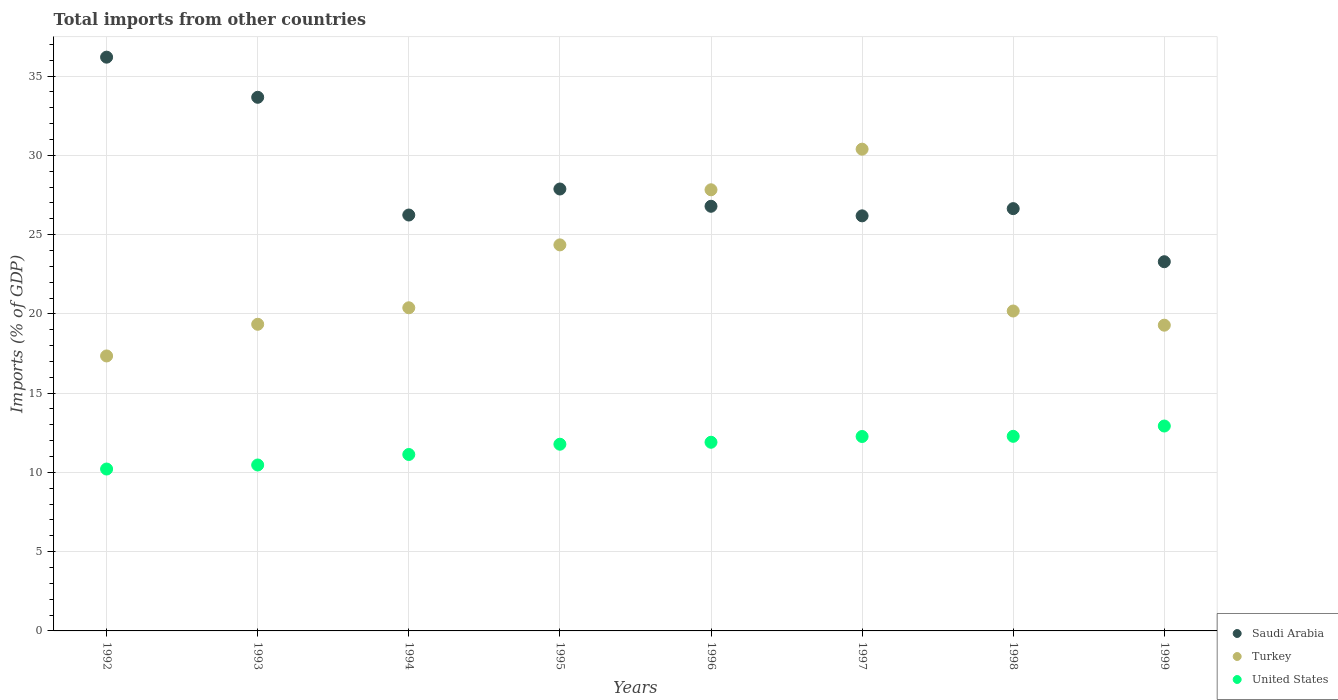How many different coloured dotlines are there?
Provide a short and direct response. 3. Is the number of dotlines equal to the number of legend labels?
Your answer should be compact. Yes. What is the total imports in Saudi Arabia in 1993?
Ensure brevity in your answer.  33.66. Across all years, what is the maximum total imports in United States?
Offer a terse response. 12.92. Across all years, what is the minimum total imports in Turkey?
Your answer should be very brief. 17.35. In which year was the total imports in Turkey maximum?
Your response must be concise. 1997. What is the total total imports in United States in the graph?
Your answer should be compact. 92.95. What is the difference between the total imports in Turkey in 1992 and that in 1996?
Your answer should be very brief. -10.48. What is the difference between the total imports in United States in 1994 and the total imports in Turkey in 1996?
Offer a very short reply. -16.7. What is the average total imports in Saudi Arabia per year?
Your response must be concise. 28.36. In the year 1996, what is the difference between the total imports in United States and total imports in Saudi Arabia?
Keep it short and to the point. -14.89. What is the ratio of the total imports in Turkey in 1994 to that in 1995?
Your answer should be very brief. 0.84. What is the difference between the highest and the second highest total imports in Saudi Arabia?
Ensure brevity in your answer.  2.53. What is the difference between the highest and the lowest total imports in Saudi Arabia?
Offer a terse response. 12.9. Is the total imports in United States strictly greater than the total imports in Turkey over the years?
Provide a succinct answer. No. Is the total imports in Saudi Arabia strictly less than the total imports in United States over the years?
Your response must be concise. No. How many dotlines are there?
Keep it short and to the point. 3. How many years are there in the graph?
Provide a succinct answer. 8. Are the values on the major ticks of Y-axis written in scientific E-notation?
Offer a terse response. No. Does the graph contain any zero values?
Provide a succinct answer. No. Does the graph contain grids?
Your answer should be very brief. Yes. Where does the legend appear in the graph?
Offer a very short reply. Bottom right. How many legend labels are there?
Your answer should be compact. 3. How are the legend labels stacked?
Your answer should be very brief. Vertical. What is the title of the graph?
Your response must be concise. Total imports from other countries. What is the label or title of the X-axis?
Provide a succinct answer. Years. What is the label or title of the Y-axis?
Your answer should be compact. Imports (% of GDP). What is the Imports (% of GDP) in Saudi Arabia in 1992?
Provide a short and direct response. 36.19. What is the Imports (% of GDP) of Turkey in 1992?
Offer a very short reply. 17.35. What is the Imports (% of GDP) of United States in 1992?
Your response must be concise. 10.21. What is the Imports (% of GDP) of Saudi Arabia in 1993?
Offer a terse response. 33.66. What is the Imports (% of GDP) in Turkey in 1993?
Your answer should be very brief. 19.34. What is the Imports (% of GDP) of United States in 1993?
Offer a very short reply. 10.47. What is the Imports (% of GDP) in Saudi Arabia in 1994?
Your answer should be compact. 26.23. What is the Imports (% of GDP) in Turkey in 1994?
Your answer should be compact. 20.38. What is the Imports (% of GDP) in United States in 1994?
Keep it short and to the point. 11.13. What is the Imports (% of GDP) of Saudi Arabia in 1995?
Ensure brevity in your answer.  27.88. What is the Imports (% of GDP) in Turkey in 1995?
Give a very brief answer. 24.35. What is the Imports (% of GDP) in United States in 1995?
Offer a terse response. 11.78. What is the Imports (% of GDP) of Saudi Arabia in 1996?
Your answer should be very brief. 26.79. What is the Imports (% of GDP) of Turkey in 1996?
Your answer should be compact. 27.83. What is the Imports (% of GDP) of United States in 1996?
Give a very brief answer. 11.9. What is the Imports (% of GDP) of Saudi Arabia in 1997?
Offer a very short reply. 26.18. What is the Imports (% of GDP) in Turkey in 1997?
Your response must be concise. 30.39. What is the Imports (% of GDP) in United States in 1997?
Your answer should be very brief. 12.26. What is the Imports (% of GDP) in Saudi Arabia in 1998?
Offer a very short reply. 26.64. What is the Imports (% of GDP) of Turkey in 1998?
Offer a very short reply. 20.18. What is the Imports (% of GDP) in United States in 1998?
Your response must be concise. 12.27. What is the Imports (% of GDP) in Saudi Arabia in 1999?
Your answer should be compact. 23.29. What is the Imports (% of GDP) in Turkey in 1999?
Make the answer very short. 19.29. What is the Imports (% of GDP) of United States in 1999?
Your response must be concise. 12.92. Across all years, what is the maximum Imports (% of GDP) of Saudi Arabia?
Ensure brevity in your answer.  36.19. Across all years, what is the maximum Imports (% of GDP) in Turkey?
Your answer should be very brief. 30.39. Across all years, what is the maximum Imports (% of GDP) of United States?
Provide a short and direct response. 12.92. Across all years, what is the minimum Imports (% of GDP) of Saudi Arabia?
Offer a very short reply. 23.29. Across all years, what is the minimum Imports (% of GDP) of Turkey?
Provide a short and direct response. 17.35. Across all years, what is the minimum Imports (% of GDP) in United States?
Offer a very short reply. 10.21. What is the total Imports (% of GDP) of Saudi Arabia in the graph?
Ensure brevity in your answer.  226.86. What is the total Imports (% of GDP) in Turkey in the graph?
Your response must be concise. 179.1. What is the total Imports (% of GDP) in United States in the graph?
Offer a terse response. 92.95. What is the difference between the Imports (% of GDP) of Saudi Arabia in 1992 and that in 1993?
Provide a short and direct response. 2.53. What is the difference between the Imports (% of GDP) of Turkey in 1992 and that in 1993?
Provide a short and direct response. -2. What is the difference between the Imports (% of GDP) in United States in 1992 and that in 1993?
Offer a terse response. -0.25. What is the difference between the Imports (% of GDP) in Saudi Arabia in 1992 and that in 1994?
Provide a succinct answer. 9.96. What is the difference between the Imports (% of GDP) of Turkey in 1992 and that in 1994?
Ensure brevity in your answer.  -3.04. What is the difference between the Imports (% of GDP) in United States in 1992 and that in 1994?
Ensure brevity in your answer.  -0.92. What is the difference between the Imports (% of GDP) of Saudi Arabia in 1992 and that in 1995?
Offer a terse response. 8.32. What is the difference between the Imports (% of GDP) in Turkey in 1992 and that in 1995?
Provide a short and direct response. -7.01. What is the difference between the Imports (% of GDP) of United States in 1992 and that in 1995?
Provide a short and direct response. -1.56. What is the difference between the Imports (% of GDP) in Saudi Arabia in 1992 and that in 1996?
Offer a very short reply. 9.41. What is the difference between the Imports (% of GDP) of Turkey in 1992 and that in 1996?
Offer a very short reply. -10.48. What is the difference between the Imports (% of GDP) of United States in 1992 and that in 1996?
Offer a very short reply. -1.69. What is the difference between the Imports (% of GDP) in Saudi Arabia in 1992 and that in 1997?
Offer a very short reply. 10.01. What is the difference between the Imports (% of GDP) of Turkey in 1992 and that in 1997?
Provide a short and direct response. -13.04. What is the difference between the Imports (% of GDP) in United States in 1992 and that in 1997?
Your answer should be compact. -2.05. What is the difference between the Imports (% of GDP) of Saudi Arabia in 1992 and that in 1998?
Make the answer very short. 9.55. What is the difference between the Imports (% of GDP) of Turkey in 1992 and that in 1998?
Provide a succinct answer. -2.84. What is the difference between the Imports (% of GDP) in United States in 1992 and that in 1998?
Provide a short and direct response. -2.06. What is the difference between the Imports (% of GDP) of Saudi Arabia in 1992 and that in 1999?
Ensure brevity in your answer.  12.9. What is the difference between the Imports (% of GDP) in Turkey in 1992 and that in 1999?
Ensure brevity in your answer.  -1.94. What is the difference between the Imports (% of GDP) in United States in 1992 and that in 1999?
Ensure brevity in your answer.  -2.71. What is the difference between the Imports (% of GDP) in Saudi Arabia in 1993 and that in 1994?
Ensure brevity in your answer.  7.43. What is the difference between the Imports (% of GDP) of Turkey in 1993 and that in 1994?
Provide a short and direct response. -1.04. What is the difference between the Imports (% of GDP) of United States in 1993 and that in 1994?
Make the answer very short. -0.66. What is the difference between the Imports (% of GDP) in Saudi Arabia in 1993 and that in 1995?
Offer a terse response. 5.78. What is the difference between the Imports (% of GDP) in Turkey in 1993 and that in 1995?
Your answer should be compact. -5.01. What is the difference between the Imports (% of GDP) of United States in 1993 and that in 1995?
Ensure brevity in your answer.  -1.31. What is the difference between the Imports (% of GDP) in Saudi Arabia in 1993 and that in 1996?
Keep it short and to the point. 6.87. What is the difference between the Imports (% of GDP) of Turkey in 1993 and that in 1996?
Ensure brevity in your answer.  -8.48. What is the difference between the Imports (% of GDP) of United States in 1993 and that in 1996?
Your answer should be compact. -1.43. What is the difference between the Imports (% of GDP) in Saudi Arabia in 1993 and that in 1997?
Give a very brief answer. 7.48. What is the difference between the Imports (% of GDP) in Turkey in 1993 and that in 1997?
Your answer should be compact. -11.05. What is the difference between the Imports (% of GDP) of United States in 1993 and that in 1997?
Ensure brevity in your answer.  -1.8. What is the difference between the Imports (% of GDP) of Saudi Arabia in 1993 and that in 1998?
Make the answer very short. 7.02. What is the difference between the Imports (% of GDP) of Turkey in 1993 and that in 1998?
Ensure brevity in your answer.  -0.84. What is the difference between the Imports (% of GDP) in United States in 1993 and that in 1998?
Give a very brief answer. -1.81. What is the difference between the Imports (% of GDP) of Saudi Arabia in 1993 and that in 1999?
Provide a short and direct response. 10.37. What is the difference between the Imports (% of GDP) of Turkey in 1993 and that in 1999?
Give a very brief answer. 0.06. What is the difference between the Imports (% of GDP) of United States in 1993 and that in 1999?
Your answer should be compact. -2.46. What is the difference between the Imports (% of GDP) in Saudi Arabia in 1994 and that in 1995?
Your answer should be compact. -1.64. What is the difference between the Imports (% of GDP) of Turkey in 1994 and that in 1995?
Your answer should be very brief. -3.97. What is the difference between the Imports (% of GDP) of United States in 1994 and that in 1995?
Offer a terse response. -0.65. What is the difference between the Imports (% of GDP) of Saudi Arabia in 1994 and that in 1996?
Offer a terse response. -0.55. What is the difference between the Imports (% of GDP) of Turkey in 1994 and that in 1996?
Your answer should be very brief. -7.44. What is the difference between the Imports (% of GDP) in United States in 1994 and that in 1996?
Keep it short and to the point. -0.77. What is the difference between the Imports (% of GDP) in Saudi Arabia in 1994 and that in 1997?
Keep it short and to the point. 0.05. What is the difference between the Imports (% of GDP) in Turkey in 1994 and that in 1997?
Your response must be concise. -10. What is the difference between the Imports (% of GDP) of United States in 1994 and that in 1997?
Your response must be concise. -1.13. What is the difference between the Imports (% of GDP) of Saudi Arabia in 1994 and that in 1998?
Ensure brevity in your answer.  -0.4. What is the difference between the Imports (% of GDP) in Turkey in 1994 and that in 1998?
Give a very brief answer. 0.2. What is the difference between the Imports (% of GDP) in United States in 1994 and that in 1998?
Your answer should be very brief. -1.15. What is the difference between the Imports (% of GDP) of Saudi Arabia in 1994 and that in 1999?
Make the answer very short. 2.95. What is the difference between the Imports (% of GDP) in Turkey in 1994 and that in 1999?
Your answer should be very brief. 1.1. What is the difference between the Imports (% of GDP) in United States in 1994 and that in 1999?
Make the answer very short. -1.8. What is the difference between the Imports (% of GDP) of Saudi Arabia in 1995 and that in 1996?
Offer a terse response. 1.09. What is the difference between the Imports (% of GDP) in Turkey in 1995 and that in 1996?
Your answer should be very brief. -3.48. What is the difference between the Imports (% of GDP) of United States in 1995 and that in 1996?
Provide a succinct answer. -0.12. What is the difference between the Imports (% of GDP) of Saudi Arabia in 1995 and that in 1997?
Give a very brief answer. 1.69. What is the difference between the Imports (% of GDP) in Turkey in 1995 and that in 1997?
Ensure brevity in your answer.  -6.04. What is the difference between the Imports (% of GDP) of United States in 1995 and that in 1997?
Provide a short and direct response. -0.49. What is the difference between the Imports (% of GDP) in Saudi Arabia in 1995 and that in 1998?
Make the answer very short. 1.24. What is the difference between the Imports (% of GDP) in Turkey in 1995 and that in 1998?
Keep it short and to the point. 4.17. What is the difference between the Imports (% of GDP) in United States in 1995 and that in 1998?
Give a very brief answer. -0.5. What is the difference between the Imports (% of GDP) of Saudi Arabia in 1995 and that in 1999?
Your response must be concise. 4.59. What is the difference between the Imports (% of GDP) of Turkey in 1995 and that in 1999?
Give a very brief answer. 5.07. What is the difference between the Imports (% of GDP) of United States in 1995 and that in 1999?
Keep it short and to the point. -1.15. What is the difference between the Imports (% of GDP) in Saudi Arabia in 1996 and that in 1997?
Make the answer very short. 0.6. What is the difference between the Imports (% of GDP) in Turkey in 1996 and that in 1997?
Provide a short and direct response. -2.56. What is the difference between the Imports (% of GDP) in United States in 1996 and that in 1997?
Provide a short and direct response. -0.36. What is the difference between the Imports (% of GDP) of Saudi Arabia in 1996 and that in 1998?
Provide a short and direct response. 0.15. What is the difference between the Imports (% of GDP) of Turkey in 1996 and that in 1998?
Your answer should be compact. 7.65. What is the difference between the Imports (% of GDP) of United States in 1996 and that in 1998?
Your response must be concise. -0.37. What is the difference between the Imports (% of GDP) of Saudi Arabia in 1996 and that in 1999?
Offer a terse response. 3.5. What is the difference between the Imports (% of GDP) in Turkey in 1996 and that in 1999?
Provide a succinct answer. 8.54. What is the difference between the Imports (% of GDP) in United States in 1996 and that in 1999?
Give a very brief answer. -1.02. What is the difference between the Imports (% of GDP) in Saudi Arabia in 1997 and that in 1998?
Offer a very short reply. -0.46. What is the difference between the Imports (% of GDP) of Turkey in 1997 and that in 1998?
Your answer should be very brief. 10.21. What is the difference between the Imports (% of GDP) in United States in 1997 and that in 1998?
Offer a terse response. -0.01. What is the difference between the Imports (% of GDP) in Saudi Arabia in 1997 and that in 1999?
Provide a short and direct response. 2.89. What is the difference between the Imports (% of GDP) of Turkey in 1997 and that in 1999?
Ensure brevity in your answer.  11.1. What is the difference between the Imports (% of GDP) in United States in 1997 and that in 1999?
Keep it short and to the point. -0.66. What is the difference between the Imports (% of GDP) in Saudi Arabia in 1998 and that in 1999?
Your answer should be compact. 3.35. What is the difference between the Imports (% of GDP) of Turkey in 1998 and that in 1999?
Provide a short and direct response. 0.89. What is the difference between the Imports (% of GDP) in United States in 1998 and that in 1999?
Give a very brief answer. -0.65. What is the difference between the Imports (% of GDP) of Saudi Arabia in 1992 and the Imports (% of GDP) of Turkey in 1993?
Make the answer very short. 16.85. What is the difference between the Imports (% of GDP) in Saudi Arabia in 1992 and the Imports (% of GDP) in United States in 1993?
Offer a terse response. 25.73. What is the difference between the Imports (% of GDP) in Turkey in 1992 and the Imports (% of GDP) in United States in 1993?
Your response must be concise. 6.88. What is the difference between the Imports (% of GDP) in Saudi Arabia in 1992 and the Imports (% of GDP) in Turkey in 1994?
Your answer should be compact. 15.81. What is the difference between the Imports (% of GDP) in Saudi Arabia in 1992 and the Imports (% of GDP) in United States in 1994?
Ensure brevity in your answer.  25.06. What is the difference between the Imports (% of GDP) in Turkey in 1992 and the Imports (% of GDP) in United States in 1994?
Your response must be concise. 6.22. What is the difference between the Imports (% of GDP) of Saudi Arabia in 1992 and the Imports (% of GDP) of Turkey in 1995?
Provide a short and direct response. 11.84. What is the difference between the Imports (% of GDP) of Saudi Arabia in 1992 and the Imports (% of GDP) of United States in 1995?
Provide a succinct answer. 24.42. What is the difference between the Imports (% of GDP) of Turkey in 1992 and the Imports (% of GDP) of United States in 1995?
Give a very brief answer. 5.57. What is the difference between the Imports (% of GDP) of Saudi Arabia in 1992 and the Imports (% of GDP) of Turkey in 1996?
Provide a short and direct response. 8.37. What is the difference between the Imports (% of GDP) in Saudi Arabia in 1992 and the Imports (% of GDP) in United States in 1996?
Provide a short and direct response. 24.29. What is the difference between the Imports (% of GDP) of Turkey in 1992 and the Imports (% of GDP) of United States in 1996?
Your response must be concise. 5.44. What is the difference between the Imports (% of GDP) of Saudi Arabia in 1992 and the Imports (% of GDP) of Turkey in 1997?
Keep it short and to the point. 5.8. What is the difference between the Imports (% of GDP) of Saudi Arabia in 1992 and the Imports (% of GDP) of United States in 1997?
Make the answer very short. 23.93. What is the difference between the Imports (% of GDP) of Turkey in 1992 and the Imports (% of GDP) of United States in 1997?
Your answer should be very brief. 5.08. What is the difference between the Imports (% of GDP) of Saudi Arabia in 1992 and the Imports (% of GDP) of Turkey in 1998?
Your answer should be compact. 16.01. What is the difference between the Imports (% of GDP) in Saudi Arabia in 1992 and the Imports (% of GDP) in United States in 1998?
Your answer should be compact. 23.92. What is the difference between the Imports (% of GDP) in Turkey in 1992 and the Imports (% of GDP) in United States in 1998?
Provide a short and direct response. 5.07. What is the difference between the Imports (% of GDP) in Saudi Arabia in 1992 and the Imports (% of GDP) in Turkey in 1999?
Your answer should be very brief. 16.91. What is the difference between the Imports (% of GDP) in Saudi Arabia in 1992 and the Imports (% of GDP) in United States in 1999?
Your answer should be compact. 23.27. What is the difference between the Imports (% of GDP) of Turkey in 1992 and the Imports (% of GDP) of United States in 1999?
Your response must be concise. 4.42. What is the difference between the Imports (% of GDP) in Saudi Arabia in 1993 and the Imports (% of GDP) in Turkey in 1994?
Provide a succinct answer. 13.28. What is the difference between the Imports (% of GDP) in Saudi Arabia in 1993 and the Imports (% of GDP) in United States in 1994?
Offer a very short reply. 22.53. What is the difference between the Imports (% of GDP) in Turkey in 1993 and the Imports (% of GDP) in United States in 1994?
Keep it short and to the point. 8.21. What is the difference between the Imports (% of GDP) in Saudi Arabia in 1993 and the Imports (% of GDP) in Turkey in 1995?
Keep it short and to the point. 9.31. What is the difference between the Imports (% of GDP) in Saudi Arabia in 1993 and the Imports (% of GDP) in United States in 1995?
Your response must be concise. 21.88. What is the difference between the Imports (% of GDP) in Turkey in 1993 and the Imports (% of GDP) in United States in 1995?
Offer a very short reply. 7.57. What is the difference between the Imports (% of GDP) of Saudi Arabia in 1993 and the Imports (% of GDP) of Turkey in 1996?
Your answer should be compact. 5.83. What is the difference between the Imports (% of GDP) of Saudi Arabia in 1993 and the Imports (% of GDP) of United States in 1996?
Ensure brevity in your answer.  21.76. What is the difference between the Imports (% of GDP) of Turkey in 1993 and the Imports (% of GDP) of United States in 1996?
Provide a short and direct response. 7.44. What is the difference between the Imports (% of GDP) in Saudi Arabia in 1993 and the Imports (% of GDP) in Turkey in 1997?
Provide a succinct answer. 3.27. What is the difference between the Imports (% of GDP) of Saudi Arabia in 1993 and the Imports (% of GDP) of United States in 1997?
Your response must be concise. 21.4. What is the difference between the Imports (% of GDP) in Turkey in 1993 and the Imports (% of GDP) in United States in 1997?
Your response must be concise. 7.08. What is the difference between the Imports (% of GDP) in Saudi Arabia in 1993 and the Imports (% of GDP) in Turkey in 1998?
Offer a terse response. 13.48. What is the difference between the Imports (% of GDP) of Saudi Arabia in 1993 and the Imports (% of GDP) of United States in 1998?
Your response must be concise. 21.39. What is the difference between the Imports (% of GDP) in Turkey in 1993 and the Imports (% of GDP) in United States in 1998?
Offer a very short reply. 7.07. What is the difference between the Imports (% of GDP) of Saudi Arabia in 1993 and the Imports (% of GDP) of Turkey in 1999?
Provide a succinct answer. 14.37. What is the difference between the Imports (% of GDP) in Saudi Arabia in 1993 and the Imports (% of GDP) in United States in 1999?
Offer a very short reply. 20.74. What is the difference between the Imports (% of GDP) in Turkey in 1993 and the Imports (% of GDP) in United States in 1999?
Offer a terse response. 6.42. What is the difference between the Imports (% of GDP) in Saudi Arabia in 1994 and the Imports (% of GDP) in Turkey in 1995?
Provide a succinct answer. 1.88. What is the difference between the Imports (% of GDP) in Saudi Arabia in 1994 and the Imports (% of GDP) in United States in 1995?
Ensure brevity in your answer.  14.46. What is the difference between the Imports (% of GDP) of Turkey in 1994 and the Imports (% of GDP) of United States in 1995?
Your answer should be compact. 8.61. What is the difference between the Imports (% of GDP) of Saudi Arabia in 1994 and the Imports (% of GDP) of Turkey in 1996?
Keep it short and to the point. -1.59. What is the difference between the Imports (% of GDP) in Saudi Arabia in 1994 and the Imports (% of GDP) in United States in 1996?
Ensure brevity in your answer.  14.33. What is the difference between the Imports (% of GDP) of Turkey in 1994 and the Imports (% of GDP) of United States in 1996?
Offer a very short reply. 8.48. What is the difference between the Imports (% of GDP) in Saudi Arabia in 1994 and the Imports (% of GDP) in Turkey in 1997?
Your response must be concise. -4.15. What is the difference between the Imports (% of GDP) in Saudi Arabia in 1994 and the Imports (% of GDP) in United States in 1997?
Make the answer very short. 13.97. What is the difference between the Imports (% of GDP) of Turkey in 1994 and the Imports (% of GDP) of United States in 1997?
Make the answer very short. 8.12. What is the difference between the Imports (% of GDP) of Saudi Arabia in 1994 and the Imports (% of GDP) of Turkey in 1998?
Make the answer very short. 6.05. What is the difference between the Imports (% of GDP) in Saudi Arabia in 1994 and the Imports (% of GDP) in United States in 1998?
Your answer should be compact. 13.96. What is the difference between the Imports (% of GDP) of Turkey in 1994 and the Imports (% of GDP) of United States in 1998?
Offer a very short reply. 8.11. What is the difference between the Imports (% of GDP) in Saudi Arabia in 1994 and the Imports (% of GDP) in Turkey in 1999?
Make the answer very short. 6.95. What is the difference between the Imports (% of GDP) in Saudi Arabia in 1994 and the Imports (% of GDP) in United States in 1999?
Keep it short and to the point. 13.31. What is the difference between the Imports (% of GDP) of Turkey in 1994 and the Imports (% of GDP) of United States in 1999?
Give a very brief answer. 7.46. What is the difference between the Imports (% of GDP) in Saudi Arabia in 1995 and the Imports (% of GDP) in Turkey in 1996?
Provide a succinct answer. 0.05. What is the difference between the Imports (% of GDP) in Saudi Arabia in 1995 and the Imports (% of GDP) in United States in 1996?
Give a very brief answer. 15.98. What is the difference between the Imports (% of GDP) of Turkey in 1995 and the Imports (% of GDP) of United States in 1996?
Give a very brief answer. 12.45. What is the difference between the Imports (% of GDP) in Saudi Arabia in 1995 and the Imports (% of GDP) in Turkey in 1997?
Your response must be concise. -2.51. What is the difference between the Imports (% of GDP) of Saudi Arabia in 1995 and the Imports (% of GDP) of United States in 1997?
Provide a succinct answer. 15.61. What is the difference between the Imports (% of GDP) of Turkey in 1995 and the Imports (% of GDP) of United States in 1997?
Offer a very short reply. 12.09. What is the difference between the Imports (% of GDP) in Saudi Arabia in 1995 and the Imports (% of GDP) in Turkey in 1998?
Your answer should be compact. 7.7. What is the difference between the Imports (% of GDP) in Saudi Arabia in 1995 and the Imports (% of GDP) in United States in 1998?
Ensure brevity in your answer.  15.6. What is the difference between the Imports (% of GDP) of Turkey in 1995 and the Imports (% of GDP) of United States in 1998?
Provide a short and direct response. 12.08. What is the difference between the Imports (% of GDP) in Saudi Arabia in 1995 and the Imports (% of GDP) in Turkey in 1999?
Offer a terse response. 8.59. What is the difference between the Imports (% of GDP) of Saudi Arabia in 1995 and the Imports (% of GDP) of United States in 1999?
Make the answer very short. 14.95. What is the difference between the Imports (% of GDP) of Turkey in 1995 and the Imports (% of GDP) of United States in 1999?
Your answer should be very brief. 11.43. What is the difference between the Imports (% of GDP) of Saudi Arabia in 1996 and the Imports (% of GDP) of Turkey in 1997?
Ensure brevity in your answer.  -3.6. What is the difference between the Imports (% of GDP) in Saudi Arabia in 1996 and the Imports (% of GDP) in United States in 1997?
Keep it short and to the point. 14.52. What is the difference between the Imports (% of GDP) in Turkey in 1996 and the Imports (% of GDP) in United States in 1997?
Ensure brevity in your answer.  15.56. What is the difference between the Imports (% of GDP) in Saudi Arabia in 1996 and the Imports (% of GDP) in Turkey in 1998?
Your answer should be very brief. 6.61. What is the difference between the Imports (% of GDP) in Saudi Arabia in 1996 and the Imports (% of GDP) in United States in 1998?
Make the answer very short. 14.51. What is the difference between the Imports (% of GDP) of Turkey in 1996 and the Imports (% of GDP) of United States in 1998?
Your answer should be very brief. 15.55. What is the difference between the Imports (% of GDP) in Saudi Arabia in 1996 and the Imports (% of GDP) in Turkey in 1999?
Give a very brief answer. 7.5. What is the difference between the Imports (% of GDP) in Saudi Arabia in 1996 and the Imports (% of GDP) in United States in 1999?
Offer a terse response. 13.86. What is the difference between the Imports (% of GDP) of Turkey in 1996 and the Imports (% of GDP) of United States in 1999?
Your response must be concise. 14.9. What is the difference between the Imports (% of GDP) in Saudi Arabia in 1997 and the Imports (% of GDP) in Turkey in 1998?
Offer a terse response. 6. What is the difference between the Imports (% of GDP) of Saudi Arabia in 1997 and the Imports (% of GDP) of United States in 1998?
Make the answer very short. 13.91. What is the difference between the Imports (% of GDP) in Turkey in 1997 and the Imports (% of GDP) in United States in 1998?
Make the answer very short. 18.11. What is the difference between the Imports (% of GDP) of Saudi Arabia in 1997 and the Imports (% of GDP) of Turkey in 1999?
Give a very brief answer. 6.9. What is the difference between the Imports (% of GDP) in Saudi Arabia in 1997 and the Imports (% of GDP) in United States in 1999?
Your answer should be compact. 13.26. What is the difference between the Imports (% of GDP) of Turkey in 1997 and the Imports (% of GDP) of United States in 1999?
Give a very brief answer. 17.46. What is the difference between the Imports (% of GDP) of Saudi Arabia in 1998 and the Imports (% of GDP) of Turkey in 1999?
Your answer should be compact. 7.35. What is the difference between the Imports (% of GDP) in Saudi Arabia in 1998 and the Imports (% of GDP) in United States in 1999?
Provide a succinct answer. 13.71. What is the difference between the Imports (% of GDP) of Turkey in 1998 and the Imports (% of GDP) of United States in 1999?
Offer a terse response. 7.26. What is the average Imports (% of GDP) in Saudi Arabia per year?
Your answer should be very brief. 28.36. What is the average Imports (% of GDP) of Turkey per year?
Your response must be concise. 22.39. What is the average Imports (% of GDP) of United States per year?
Offer a terse response. 11.62. In the year 1992, what is the difference between the Imports (% of GDP) of Saudi Arabia and Imports (% of GDP) of Turkey?
Offer a terse response. 18.85. In the year 1992, what is the difference between the Imports (% of GDP) in Saudi Arabia and Imports (% of GDP) in United States?
Offer a terse response. 25.98. In the year 1992, what is the difference between the Imports (% of GDP) in Turkey and Imports (% of GDP) in United States?
Offer a terse response. 7.13. In the year 1993, what is the difference between the Imports (% of GDP) of Saudi Arabia and Imports (% of GDP) of Turkey?
Provide a short and direct response. 14.32. In the year 1993, what is the difference between the Imports (% of GDP) of Saudi Arabia and Imports (% of GDP) of United States?
Provide a short and direct response. 23.19. In the year 1993, what is the difference between the Imports (% of GDP) of Turkey and Imports (% of GDP) of United States?
Keep it short and to the point. 8.88. In the year 1994, what is the difference between the Imports (% of GDP) of Saudi Arabia and Imports (% of GDP) of Turkey?
Ensure brevity in your answer.  5.85. In the year 1994, what is the difference between the Imports (% of GDP) in Saudi Arabia and Imports (% of GDP) in United States?
Provide a succinct answer. 15.11. In the year 1994, what is the difference between the Imports (% of GDP) of Turkey and Imports (% of GDP) of United States?
Provide a succinct answer. 9.25. In the year 1995, what is the difference between the Imports (% of GDP) in Saudi Arabia and Imports (% of GDP) in Turkey?
Offer a terse response. 3.53. In the year 1995, what is the difference between the Imports (% of GDP) in Saudi Arabia and Imports (% of GDP) in United States?
Provide a succinct answer. 16.1. In the year 1995, what is the difference between the Imports (% of GDP) of Turkey and Imports (% of GDP) of United States?
Provide a short and direct response. 12.57. In the year 1996, what is the difference between the Imports (% of GDP) of Saudi Arabia and Imports (% of GDP) of Turkey?
Offer a terse response. -1.04. In the year 1996, what is the difference between the Imports (% of GDP) of Saudi Arabia and Imports (% of GDP) of United States?
Keep it short and to the point. 14.89. In the year 1996, what is the difference between the Imports (% of GDP) of Turkey and Imports (% of GDP) of United States?
Offer a very short reply. 15.93. In the year 1997, what is the difference between the Imports (% of GDP) of Saudi Arabia and Imports (% of GDP) of Turkey?
Provide a short and direct response. -4.21. In the year 1997, what is the difference between the Imports (% of GDP) of Saudi Arabia and Imports (% of GDP) of United States?
Provide a short and direct response. 13.92. In the year 1997, what is the difference between the Imports (% of GDP) of Turkey and Imports (% of GDP) of United States?
Make the answer very short. 18.12. In the year 1998, what is the difference between the Imports (% of GDP) of Saudi Arabia and Imports (% of GDP) of Turkey?
Provide a short and direct response. 6.46. In the year 1998, what is the difference between the Imports (% of GDP) in Saudi Arabia and Imports (% of GDP) in United States?
Keep it short and to the point. 14.36. In the year 1998, what is the difference between the Imports (% of GDP) of Turkey and Imports (% of GDP) of United States?
Ensure brevity in your answer.  7.91. In the year 1999, what is the difference between the Imports (% of GDP) in Saudi Arabia and Imports (% of GDP) in Turkey?
Your answer should be compact. 4. In the year 1999, what is the difference between the Imports (% of GDP) in Saudi Arabia and Imports (% of GDP) in United States?
Provide a succinct answer. 10.36. In the year 1999, what is the difference between the Imports (% of GDP) of Turkey and Imports (% of GDP) of United States?
Offer a very short reply. 6.36. What is the ratio of the Imports (% of GDP) of Saudi Arabia in 1992 to that in 1993?
Ensure brevity in your answer.  1.08. What is the ratio of the Imports (% of GDP) in Turkey in 1992 to that in 1993?
Your response must be concise. 0.9. What is the ratio of the Imports (% of GDP) in United States in 1992 to that in 1993?
Ensure brevity in your answer.  0.98. What is the ratio of the Imports (% of GDP) in Saudi Arabia in 1992 to that in 1994?
Make the answer very short. 1.38. What is the ratio of the Imports (% of GDP) in Turkey in 1992 to that in 1994?
Offer a very short reply. 0.85. What is the ratio of the Imports (% of GDP) in United States in 1992 to that in 1994?
Provide a short and direct response. 0.92. What is the ratio of the Imports (% of GDP) of Saudi Arabia in 1992 to that in 1995?
Your response must be concise. 1.3. What is the ratio of the Imports (% of GDP) of Turkey in 1992 to that in 1995?
Your answer should be very brief. 0.71. What is the ratio of the Imports (% of GDP) in United States in 1992 to that in 1995?
Offer a terse response. 0.87. What is the ratio of the Imports (% of GDP) in Saudi Arabia in 1992 to that in 1996?
Provide a succinct answer. 1.35. What is the ratio of the Imports (% of GDP) of Turkey in 1992 to that in 1996?
Provide a succinct answer. 0.62. What is the ratio of the Imports (% of GDP) of United States in 1992 to that in 1996?
Keep it short and to the point. 0.86. What is the ratio of the Imports (% of GDP) in Saudi Arabia in 1992 to that in 1997?
Give a very brief answer. 1.38. What is the ratio of the Imports (% of GDP) in Turkey in 1992 to that in 1997?
Your response must be concise. 0.57. What is the ratio of the Imports (% of GDP) of United States in 1992 to that in 1997?
Give a very brief answer. 0.83. What is the ratio of the Imports (% of GDP) of Saudi Arabia in 1992 to that in 1998?
Give a very brief answer. 1.36. What is the ratio of the Imports (% of GDP) of Turkey in 1992 to that in 1998?
Your answer should be compact. 0.86. What is the ratio of the Imports (% of GDP) in United States in 1992 to that in 1998?
Your response must be concise. 0.83. What is the ratio of the Imports (% of GDP) in Saudi Arabia in 1992 to that in 1999?
Your answer should be compact. 1.55. What is the ratio of the Imports (% of GDP) of Turkey in 1992 to that in 1999?
Your answer should be compact. 0.9. What is the ratio of the Imports (% of GDP) in United States in 1992 to that in 1999?
Your answer should be compact. 0.79. What is the ratio of the Imports (% of GDP) of Saudi Arabia in 1993 to that in 1994?
Your answer should be very brief. 1.28. What is the ratio of the Imports (% of GDP) in Turkey in 1993 to that in 1994?
Your response must be concise. 0.95. What is the ratio of the Imports (% of GDP) of United States in 1993 to that in 1994?
Offer a terse response. 0.94. What is the ratio of the Imports (% of GDP) in Saudi Arabia in 1993 to that in 1995?
Keep it short and to the point. 1.21. What is the ratio of the Imports (% of GDP) of Turkey in 1993 to that in 1995?
Provide a short and direct response. 0.79. What is the ratio of the Imports (% of GDP) of United States in 1993 to that in 1995?
Offer a terse response. 0.89. What is the ratio of the Imports (% of GDP) in Saudi Arabia in 1993 to that in 1996?
Give a very brief answer. 1.26. What is the ratio of the Imports (% of GDP) of Turkey in 1993 to that in 1996?
Offer a terse response. 0.7. What is the ratio of the Imports (% of GDP) in United States in 1993 to that in 1996?
Your answer should be compact. 0.88. What is the ratio of the Imports (% of GDP) in Saudi Arabia in 1993 to that in 1997?
Provide a succinct answer. 1.29. What is the ratio of the Imports (% of GDP) in Turkey in 1993 to that in 1997?
Ensure brevity in your answer.  0.64. What is the ratio of the Imports (% of GDP) in United States in 1993 to that in 1997?
Give a very brief answer. 0.85. What is the ratio of the Imports (% of GDP) of Saudi Arabia in 1993 to that in 1998?
Provide a succinct answer. 1.26. What is the ratio of the Imports (% of GDP) of Turkey in 1993 to that in 1998?
Your answer should be compact. 0.96. What is the ratio of the Imports (% of GDP) of United States in 1993 to that in 1998?
Your answer should be very brief. 0.85. What is the ratio of the Imports (% of GDP) in Saudi Arabia in 1993 to that in 1999?
Offer a very short reply. 1.45. What is the ratio of the Imports (% of GDP) of Turkey in 1993 to that in 1999?
Give a very brief answer. 1. What is the ratio of the Imports (% of GDP) of United States in 1993 to that in 1999?
Make the answer very short. 0.81. What is the ratio of the Imports (% of GDP) of Saudi Arabia in 1994 to that in 1995?
Your answer should be very brief. 0.94. What is the ratio of the Imports (% of GDP) in Turkey in 1994 to that in 1995?
Offer a terse response. 0.84. What is the ratio of the Imports (% of GDP) of United States in 1994 to that in 1995?
Provide a short and direct response. 0.94. What is the ratio of the Imports (% of GDP) in Saudi Arabia in 1994 to that in 1996?
Your response must be concise. 0.98. What is the ratio of the Imports (% of GDP) of Turkey in 1994 to that in 1996?
Your answer should be compact. 0.73. What is the ratio of the Imports (% of GDP) in United States in 1994 to that in 1996?
Offer a very short reply. 0.94. What is the ratio of the Imports (% of GDP) of Turkey in 1994 to that in 1997?
Offer a very short reply. 0.67. What is the ratio of the Imports (% of GDP) in United States in 1994 to that in 1997?
Offer a terse response. 0.91. What is the ratio of the Imports (% of GDP) in Saudi Arabia in 1994 to that in 1998?
Keep it short and to the point. 0.98. What is the ratio of the Imports (% of GDP) in Turkey in 1994 to that in 1998?
Provide a short and direct response. 1.01. What is the ratio of the Imports (% of GDP) in United States in 1994 to that in 1998?
Keep it short and to the point. 0.91. What is the ratio of the Imports (% of GDP) in Saudi Arabia in 1994 to that in 1999?
Your answer should be compact. 1.13. What is the ratio of the Imports (% of GDP) in Turkey in 1994 to that in 1999?
Make the answer very short. 1.06. What is the ratio of the Imports (% of GDP) in United States in 1994 to that in 1999?
Offer a terse response. 0.86. What is the ratio of the Imports (% of GDP) in Saudi Arabia in 1995 to that in 1996?
Provide a succinct answer. 1.04. What is the ratio of the Imports (% of GDP) in Turkey in 1995 to that in 1996?
Ensure brevity in your answer.  0.88. What is the ratio of the Imports (% of GDP) of Saudi Arabia in 1995 to that in 1997?
Provide a succinct answer. 1.06. What is the ratio of the Imports (% of GDP) of Turkey in 1995 to that in 1997?
Your answer should be compact. 0.8. What is the ratio of the Imports (% of GDP) of United States in 1995 to that in 1997?
Give a very brief answer. 0.96. What is the ratio of the Imports (% of GDP) in Saudi Arabia in 1995 to that in 1998?
Give a very brief answer. 1.05. What is the ratio of the Imports (% of GDP) of Turkey in 1995 to that in 1998?
Make the answer very short. 1.21. What is the ratio of the Imports (% of GDP) in United States in 1995 to that in 1998?
Make the answer very short. 0.96. What is the ratio of the Imports (% of GDP) in Saudi Arabia in 1995 to that in 1999?
Provide a succinct answer. 1.2. What is the ratio of the Imports (% of GDP) of Turkey in 1995 to that in 1999?
Offer a very short reply. 1.26. What is the ratio of the Imports (% of GDP) of United States in 1995 to that in 1999?
Make the answer very short. 0.91. What is the ratio of the Imports (% of GDP) in Saudi Arabia in 1996 to that in 1997?
Offer a very short reply. 1.02. What is the ratio of the Imports (% of GDP) in Turkey in 1996 to that in 1997?
Make the answer very short. 0.92. What is the ratio of the Imports (% of GDP) of United States in 1996 to that in 1997?
Give a very brief answer. 0.97. What is the ratio of the Imports (% of GDP) of Saudi Arabia in 1996 to that in 1998?
Keep it short and to the point. 1.01. What is the ratio of the Imports (% of GDP) in Turkey in 1996 to that in 1998?
Make the answer very short. 1.38. What is the ratio of the Imports (% of GDP) of United States in 1996 to that in 1998?
Provide a succinct answer. 0.97. What is the ratio of the Imports (% of GDP) of Saudi Arabia in 1996 to that in 1999?
Provide a short and direct response. 1.15. What is the ratio of the Imports (% of GDP) in Turkey in 1996 to that in 1999?
Ensure brevity in your answer.  1.44. What is the ratio of the Imports (% of GDP) in United States in 1996 to that in 1999?
Keep it short and to the point. 0.92. What is the ratio of the Imports (% of GDP) in Saudi Arabia in 1997 to that in 1998?
Give a very brief answer. 0.98. What is the ratio of the Imports (% of GDP) in Turkey in 1997 to that in 1998?
Your response must be concise. 1.51. What is the ratio of the Imports (% of GDP) of United States in 1997 to that in 1998?
Your response must be concise. 1. What is the ratio of the Imports (% of GDP) in Saudi Arabia in 1997 to that in 1999?
Your answer should be very brief. 1.12. What is the ratio of the Imports (% of GDP) in Turkey in 1997 to that in 1999?
Your answer should be compact. 1.58. What is the ratio of the Imports (% of GDP) in United States in 1997 to that in 1999?
Provide a succinct answer. 0.95. What is the ratio of the Imports (% of GDP) in Saudi Arabia in 1998 to that in 1999?
Your response must be concise. 1.14. What is the ratio of the Imports (% of GDP) in Turkey in 1998 to that in 1999?
Your answer should be very brief. 1.05. What is the ratio of the Imports (% of GDP) of United States in 1998 to that in 1999?
Offer a terse response. 0.95. What is the difference between the highest and the second highest Imports (% of GDP) in Saudi Arabia?
Your answer should be compact. 2.53. What is the difference between the highest and the second highest Imports (% of GDP) in Turkey?
Keep it short and to the point. 2.56. What is the difference between the highest and the second highest Imports (% of GDP) of United States?
Make the answer very short. 0.65. What is the difference between the highest and the lowest Imports (% of GDP) in Saudi Arabia?
Provide a succinct answer. 12.9. What is the difference between the highest and the lowest Imports (% of GDP) of Turkey?
Provide a short and direct response. 13.04. What is the difference between the highest and the lowest Imports (% of GDP) of United States?
Your answer should be compact. 2.71. 